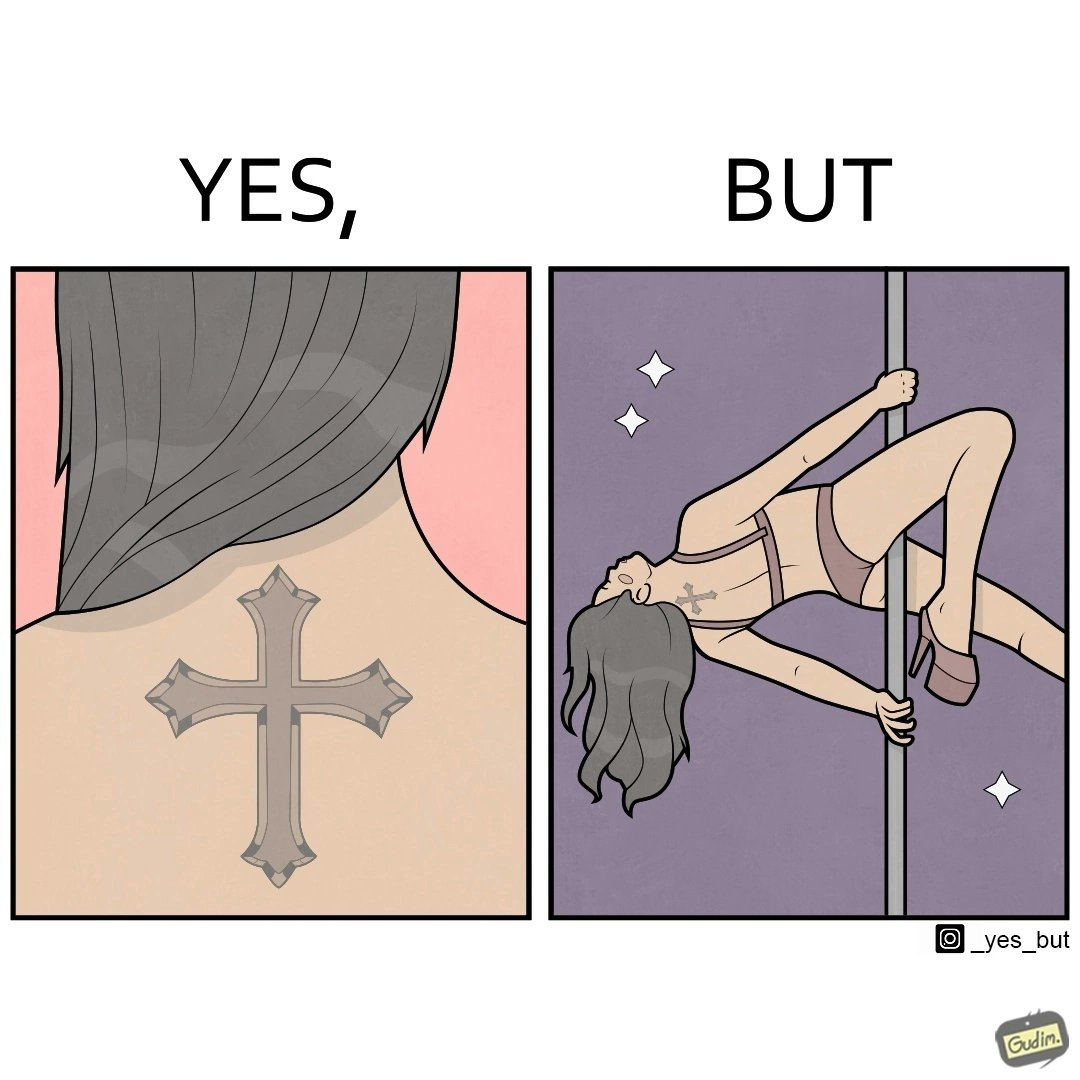Describe the satirical element in this image. This image may present two different ideas, firstly even she is such a believer in god that she has got a tatto of holy cross symbol on her back but her situations have forced her to do a job at a bar or some place performing pole dance and secondly she is using a religious symbol to glorify her look so that more people acknowledge her dance and give her some money 